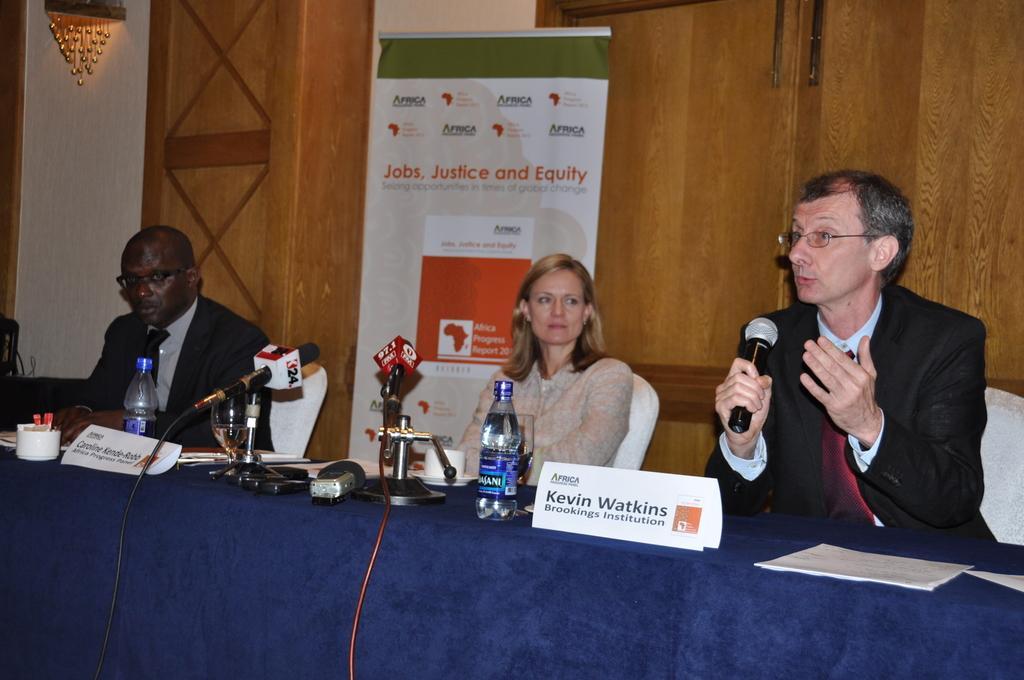How would you summarize this image in a sentence or two? In this image there are three people who are sitting on a chair. On the right side the person who is sitting and he is holding a mike and he is talking in front of them there is one table on the table there are some papers, name plates, bottles, and mike's are there on the table. On the background there are some wooden doors, and in the center there is one board. On the left side of the top corner there is one object. 